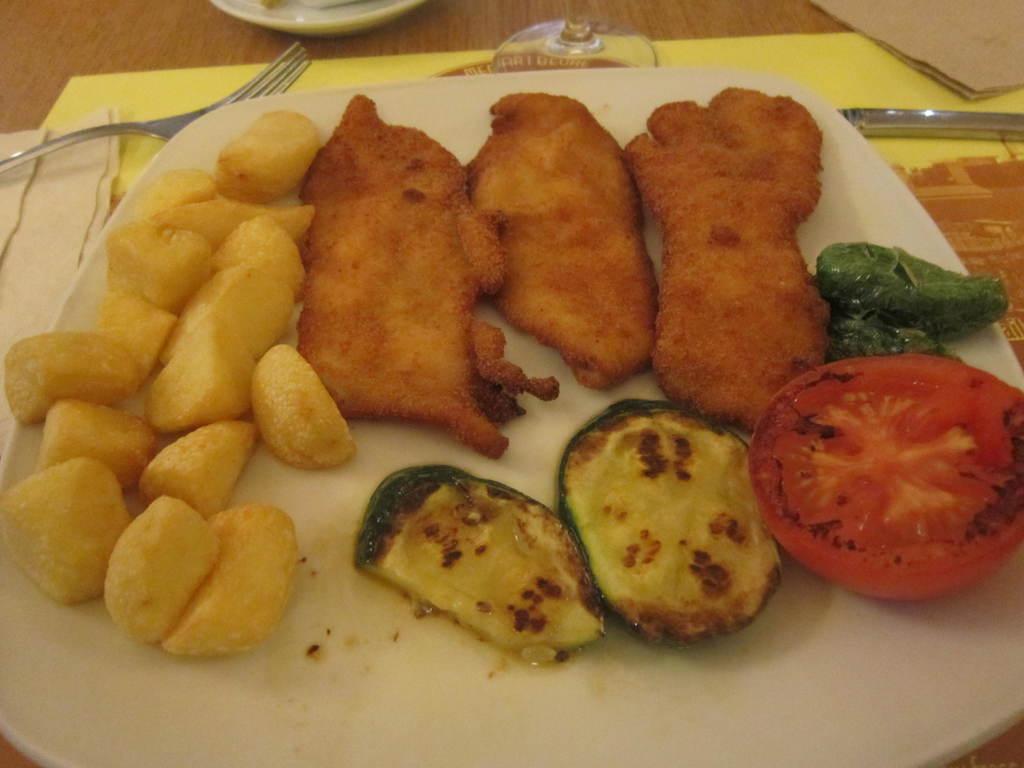Could you give a brief overview of what you see in this image? In this image we can see some food item which is in a plate which is of white color and we can see fork, knife and some other items on table. 